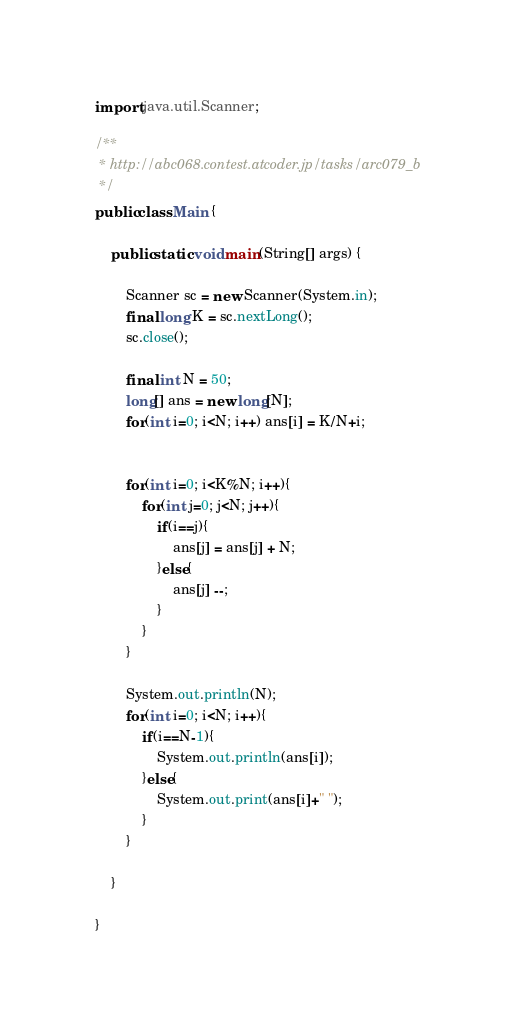Convert code to text. <code><loc_0><loc_0><loc_500><loc_500><_Java_>import java.util.Scanner;

/**
 * http://abc068.contest.atcoder.jp/tasks/arc079_b
 */
public class Main {

	public static void main(String[] args) {
		
		Scanner sc = new Scanner(System.in);
		final long K = sc.nextLong();
		sc.close();
		
		final int N = 50;
		long[] ans = new long[N];
		for(int i=0; i<N; i++) ans[i] = K/N+i;


		for(int i=0; i<K%N; i++){
			for(int j=0; j<N; j++){
				if(i==j){
					ans[j] = ans[j] + N;
				}else{
					ans[j] --;
				}
			}
		}
		
		System.out.println(N);
		for(int i=0; i<N; i++){
			if(i==N-1){
				System.out.println(ans[i]);
			}else{
				System.out.print(ans[i]+" ");
			}
		}
		
	}

}</code> 